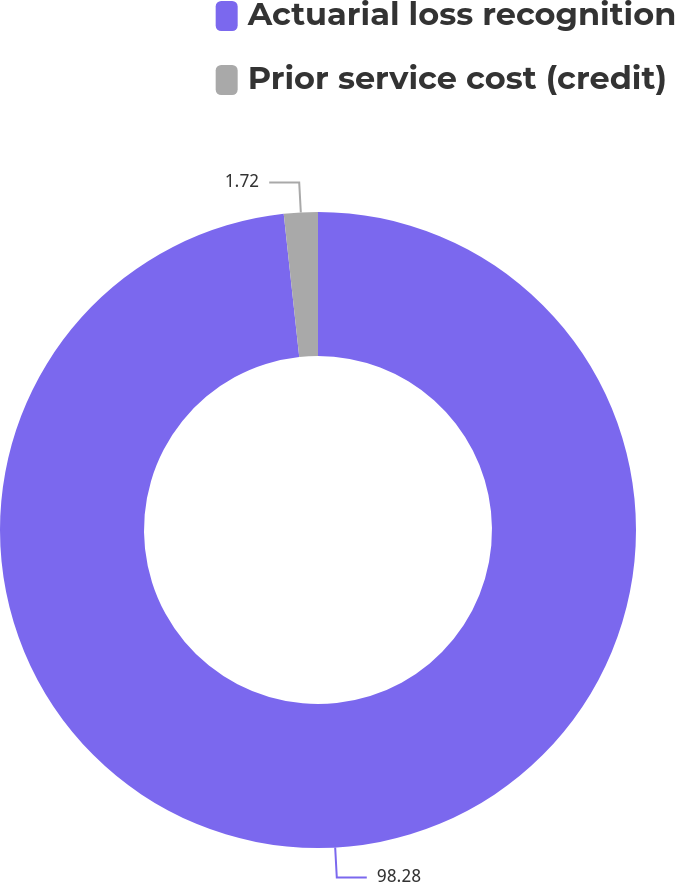<chart> <loc_0><loc_0><loc_500><loc_500><pie_chart><fcel>Actuarial loss recognition<fcel>Prior service cost (credit)<nl><fcel>98.28%<fcel>1.72%<nl></chart> 